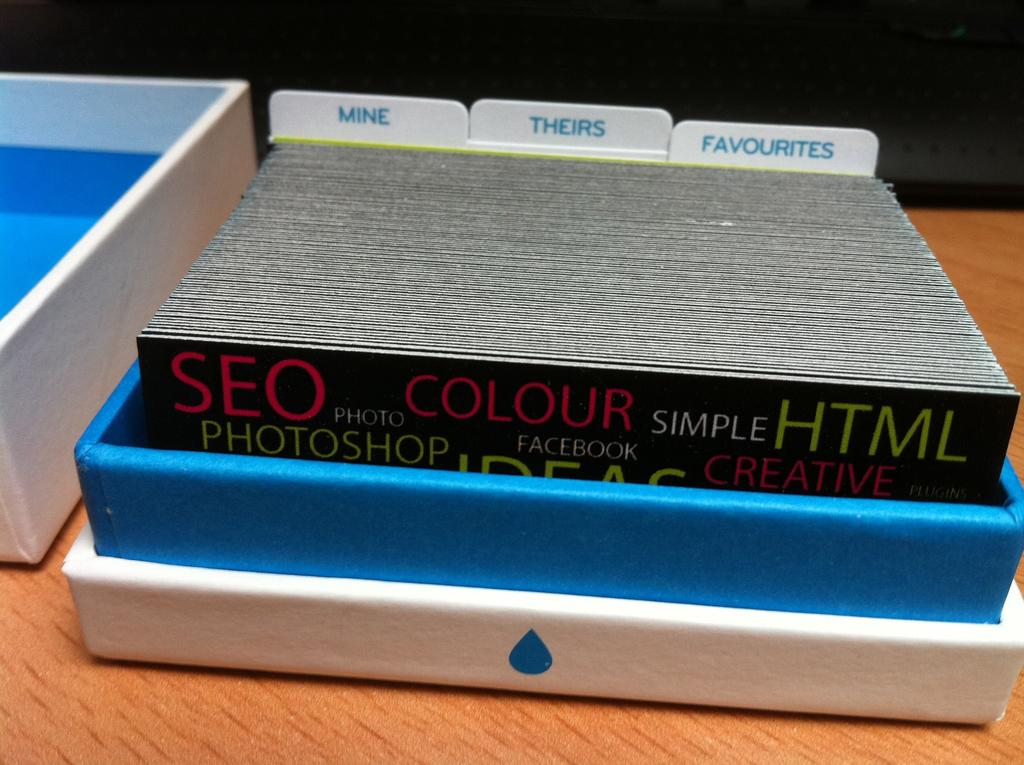<image>
Describe the image concisely. a stack of brochures for SEO and photoshop sit in a case 